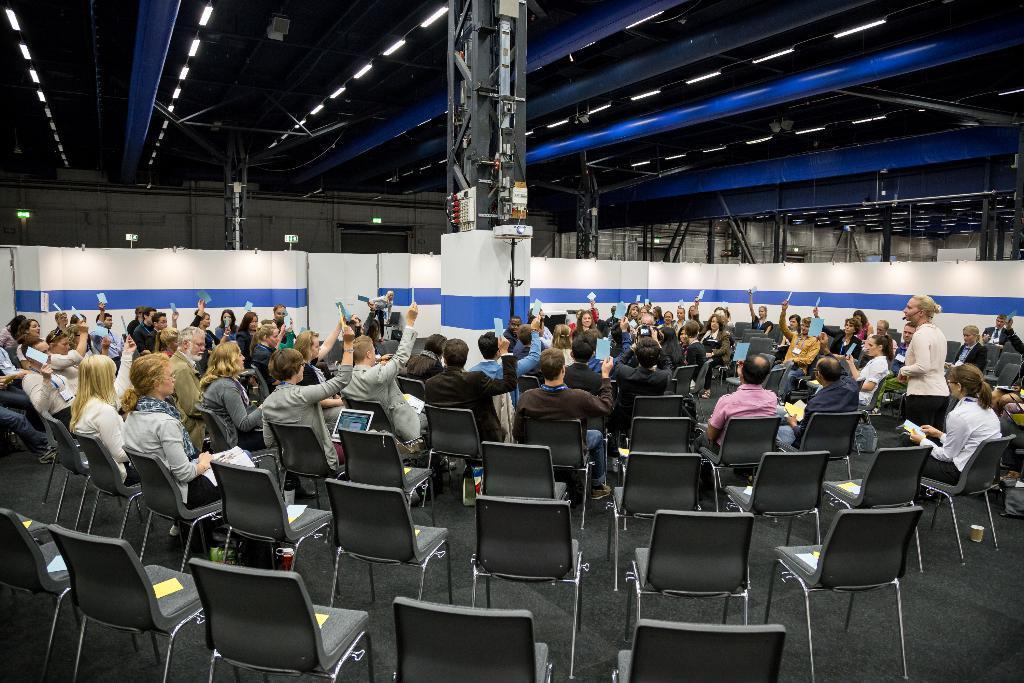Could you give a brief overview of what you see in this image? people are seated on black chairs. at the back the chairs are empty. people are raising their hands. at the right a person is standing. in the center there is a pole. it has a boundary which is white and blue in color. 